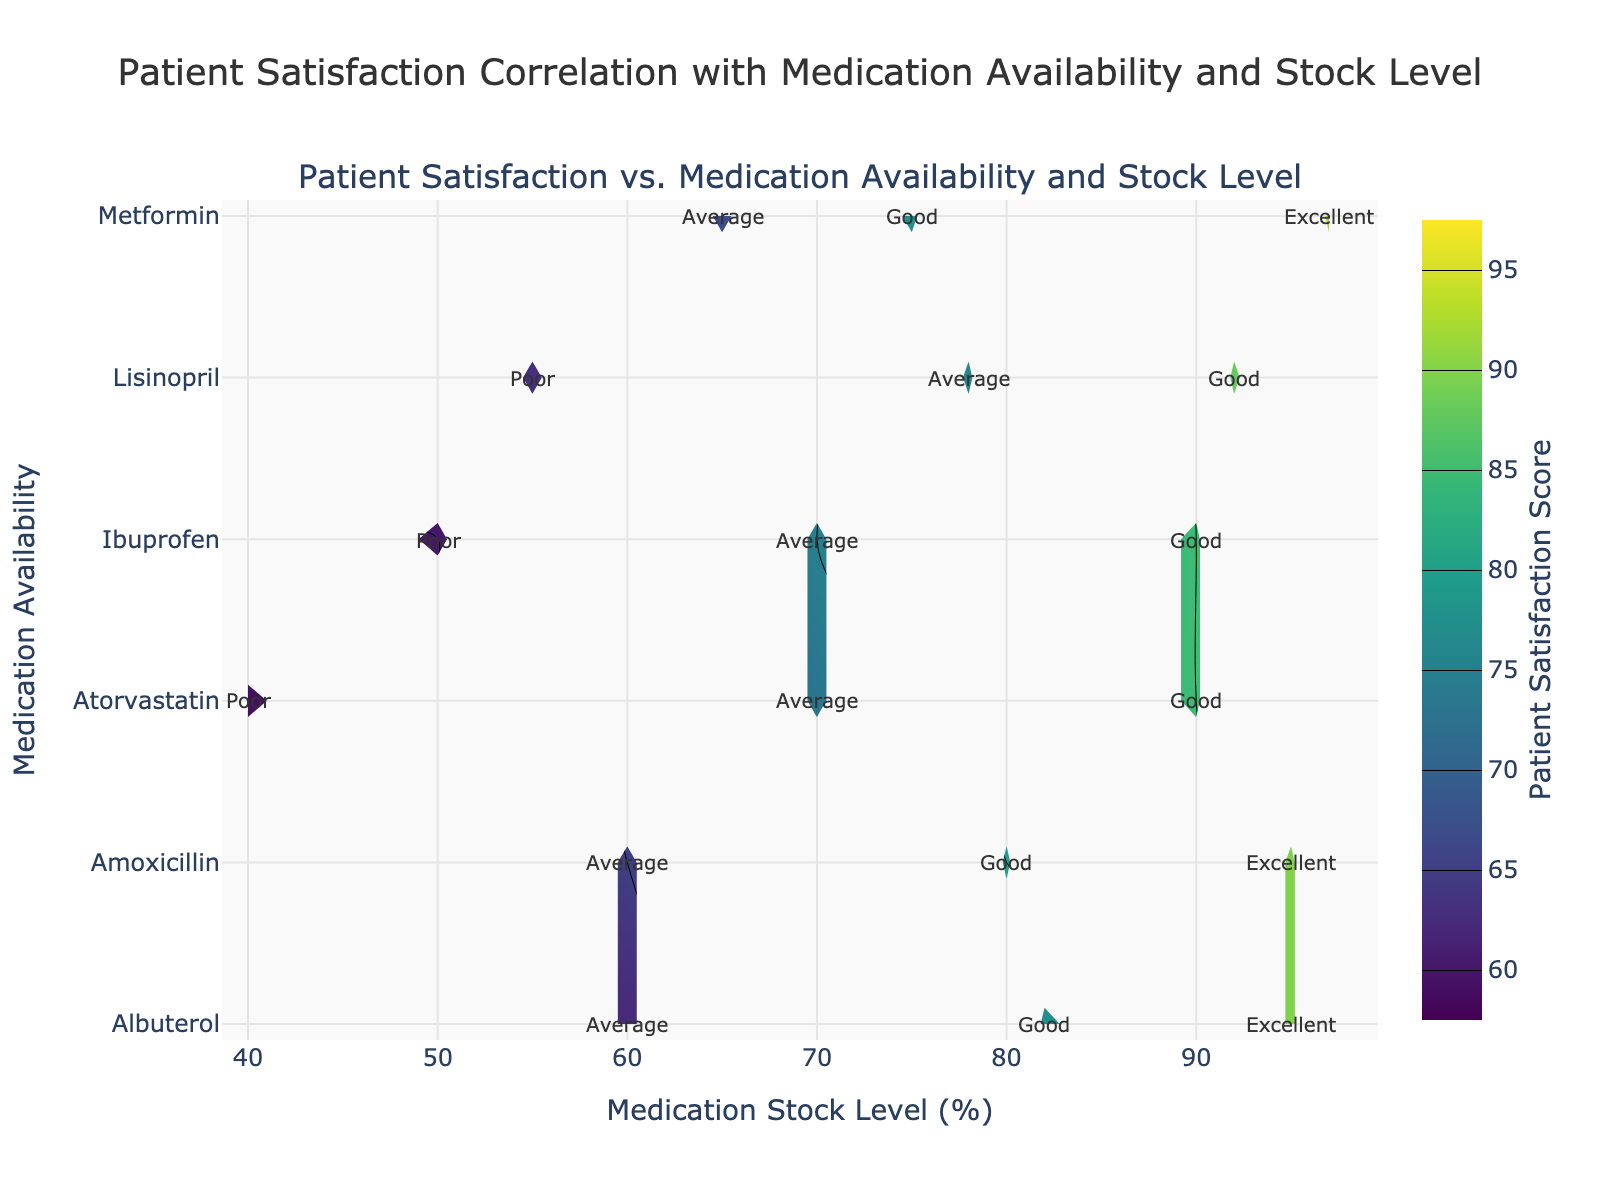What is the title of the figure? The title is displayed at the top of the figure in large, bold text.
Answer: Patient Satisfaction Correlation with Medication Availability and Stock Level What are the x-axis and y-axis labels? The x-axis label is found at the bottom of the figure, and the y-axis label is on the left side. They describe the variables being plotted.
Answer: Medication Stock Level (%), Medication Availability What colors are used in the contour plot? The colors represent different patient satisfaction scores and can be seen in the color scale on the right side of the figure.
Answer: Viridis color scale (yellow to green to blue) How does the patient satisfaction score change with decreasing medication stock levels? Examine the trend on the contour plot from right to left across different medication stock levels while noting the satisfaction scores.
Answer: Scores generally decrease Which medication has the highest patient satisfaction score and what is its stock level? Locate the contour areas with the highest scores and identify the corresponding medication and stock level from the annotations.
Answer: Metformin, Stock Level 97% How do the patient care outcomes correlate with patient satisfaction scores? Look at the annotations on the plot and notice the patient care outcomes related to different satisfaction score levels.
Answer: Better outcomes are associated with higher satisfaction scores Is there any medication that consistently shows poor patient satisfaction at all stock levels? Examine the contour plot annotations and identify any medication where only poor satisfaction scores are noted regardless of the stock level.
Answer: Ibuprofen How do the patient satisfaction scores for Amoxicillin vary with changes in stock level? Observe the variation in the contour levels associated with Amoxicillin across different stock levels as indicated in the annotations.
Answer: Scores range from 65 (Average) to 90 (Excellent) Which medication shows an excellent patient care outcome at the lowest stock level? Identify the portions of the contour plot where "Excellent" patient care is annotated and check for the lowest stock level among them.
Answer: Albuterol, Stock Level 82% 